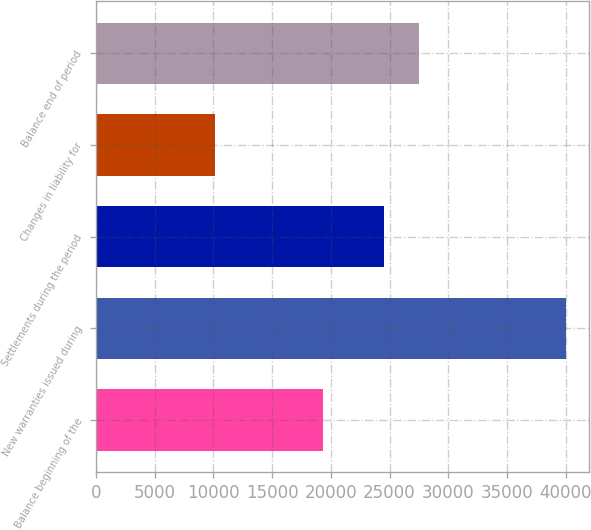Convert chart. <chart><loc_0><loc_0><loc_500><loc_500><bar_chart><fcel>Balance beginning of the<fcel>New warranties issued during<fcel>Settlements during the period<fcel>Changes in liability for<fcel>Balance end of period<nl><fcel>19369<fcel>40011<fcel>24560<fcel>10152<fcel>27545.9<nl></chart> 